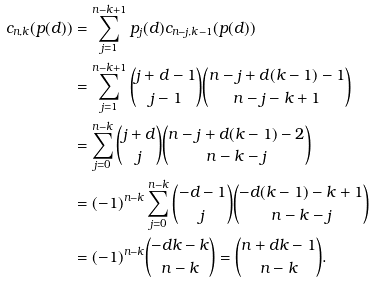<formula> <loc_0><loc_0><loc_500><loc_500>c _ { n , k } ( p ( d ) ) & = \sum _ { j = 1 } ^ { n - k + 1 } p _ { j } ( d ) c _ { n - j , k - 1 } ( p ( d ) ) \\ & = \sum _ { j = 1 } ^ { n - k + 1 } \binom { j + d - 1 } { j - 1 } \binom { n - j + d ( k - 1 ) - 1 } { n - j - k + 1 } \\ & = \sum _ { j = 0 } ^ { n - k } \binom { j + d } { j } \binom { n - j + d ( k - 1 ) - 2 } { n - k - j } \\ & = ( - 1 ) ^ { n - k } \sum _ { j = 0 } ^ { n - k } \binom { - d - 1 } { j } \binom { - d ( k - 1 ) - k + 1 } { n - k - j } \\ & = ( - 1 ) ^ { n - k } \binom { - d k - k } { n - k } = \binom { n + d k - 1 } { n - k } .</formula> 